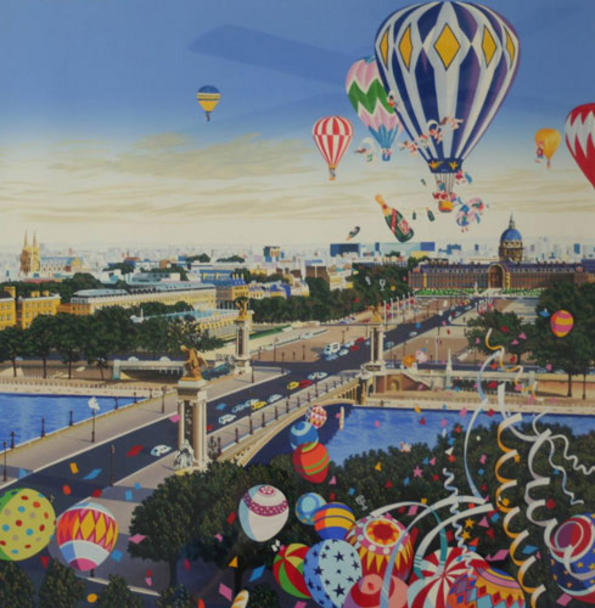Imagine you are floating in one of these hot air balloons. Describe your experience. As I float gently in one of the hot air balloons, I am immersed in a sea of color and whimsy. The world below appears like a patchwork quilt of surreal, dreamlike architecture, with streets and buildings teeming with life and vibrancy. The sensation of floating is serene and exhilarating, with a gentle breeze carrying my balloon across the sky, offering ever-changing perspectives of the enchanting cityscape. The crisp, clean air carries the scent of flowers and the distant murmur of city life, creating a harmonious blend of sensory delights that make this experience truly magical. 